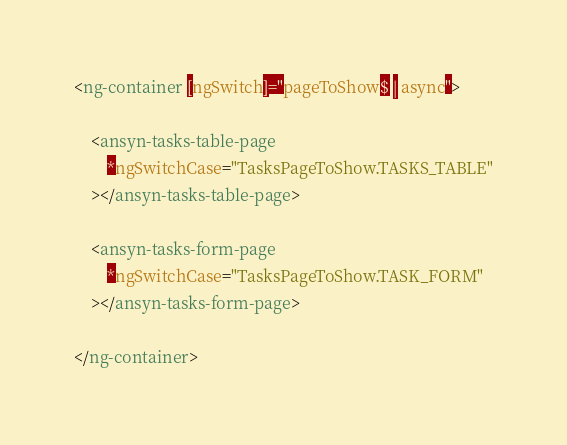<code> <loc_0><loc_0><loc_500><loc_500><_HTML_><ng-container [ngSwitch]="pageToShow$ | async">

	<ansyn-tasks-table-page
		*ngSwitchCase="TasksPageToShow.TASKS_TABLE"
	></ansyn-tasks-table-page>

	<ansyn-tasks-form-page
		*ngSwitchCase="TasksPageToShow.TASK_FORM"
	></ansyn-tasks-form-page>

</ng-container>
</code> 